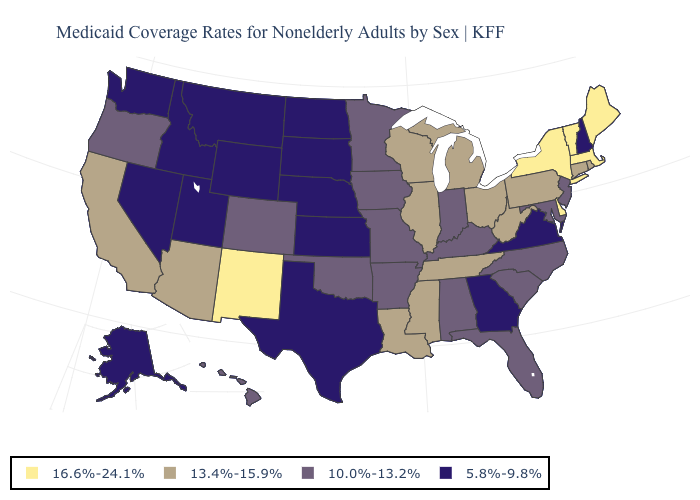Name the states that have a value in the range 10.0%-13.2%?
Quick response, please. Alabama, Arkansas, Colorado, Florida, Hawaii, Indiana, Iowa, Kentucky, Maryland, Minnesota, Missouri, New Jersey, North Carolina, Oklahoma, Oregon, South Carolina. Name the states that have a value in the range 10.0%-13.2%?
Keep it brief. Alabama, Arkansas, Colorado, Florida, Hawaii, Indiana, Iowa, Kentucky, Maryland, Minnesota, Missouri, New Jersey, North Carolina, Oklahoma, Oregon, South Carolina. What is the value of New York?
Be succinct. 16.6%-24.1%. Name the states that have a value in the range 10.0%-13.2%?
Be succinct. Alabama, Arkansas, Colorado, Florida, Hawaii, Indiana, Iowa, Kentucky, Maryland, Minnesota, Missouri, New Jersey, North Carolina, Oklahoma, Oregon, South Carolina. Among the states that border Colorado , which have the highest value?
Give a very brief answer. New Mexico. Among the states that border Missouri , which have the lowest value?
Keep it brief. Kansas, Nebraska. Does the first symbol in the legend represent the smallest category?
Write a very short answer. No. What is the value of Delaware?
Short answer required. 16.6%-24.1%. Does New York have the highest value in the USA?
Concise answer only. Yes. What is the value of Virginia?
Give a very brief answer. 5.8%-9.8%. What is the highest value in the South ?
Keep it brief. 16.6%-24.1%. What is the highest value in the MidWest ?
Keep it brief. 13.4%-15.9%. Which states have the lowest value in the South?
Write a very short answer. Georgia, Texas, Virginia. 